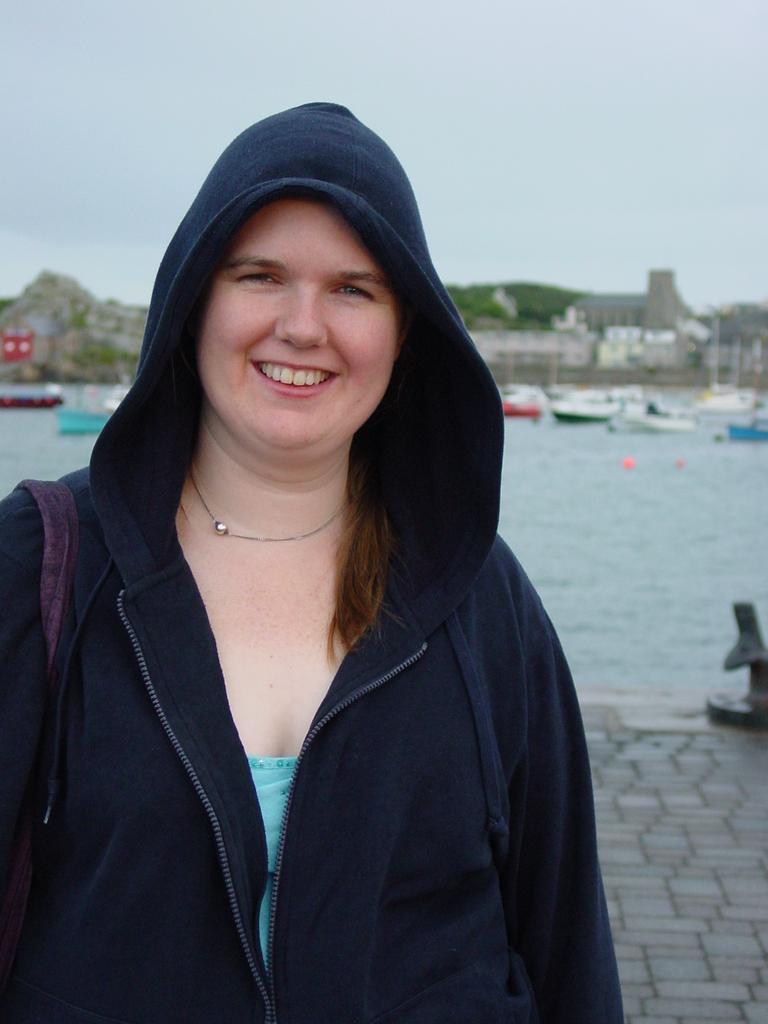Please provide a concise description of this image. In this image I can see a person wearing navy blue jacket and wearing a bag. Back I can see few boats,water and trees. The sky is in blue and white color. 